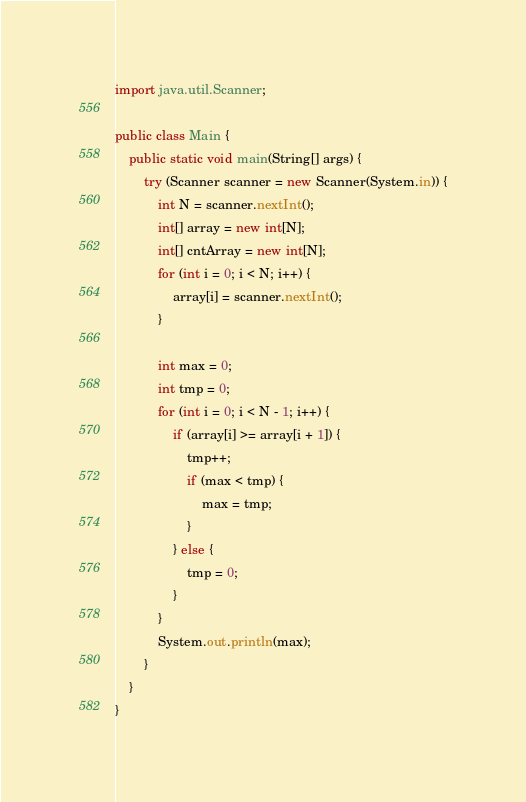<code> <loc_0><loc_0><loc_500><loc_500><_Java_>import java.util.Scanner;

public class Main {
	public static void main(String[] args) {
		try (Scanner scanner = new Scanner(System.in)) {
			int N = scanner.nextInt();
			int[] array = new int[N];
			int[] cntArray = new int[N];
			for (int i = 0; i < N; i++) {
				array[i] = scanner.nextInt();
			}

			int max = 0;
			int tmp = 0;
			for (int i = 0; i < N - 1; i++) {
				if (array[i] >= array[i + 1]) {
					tmp++;
					if (max < tmp) {
						max = tmp;
					}
				} else {
					tmp = 0;
				}
			}
			System.out.println(max);
		}
	}
}
</code> 